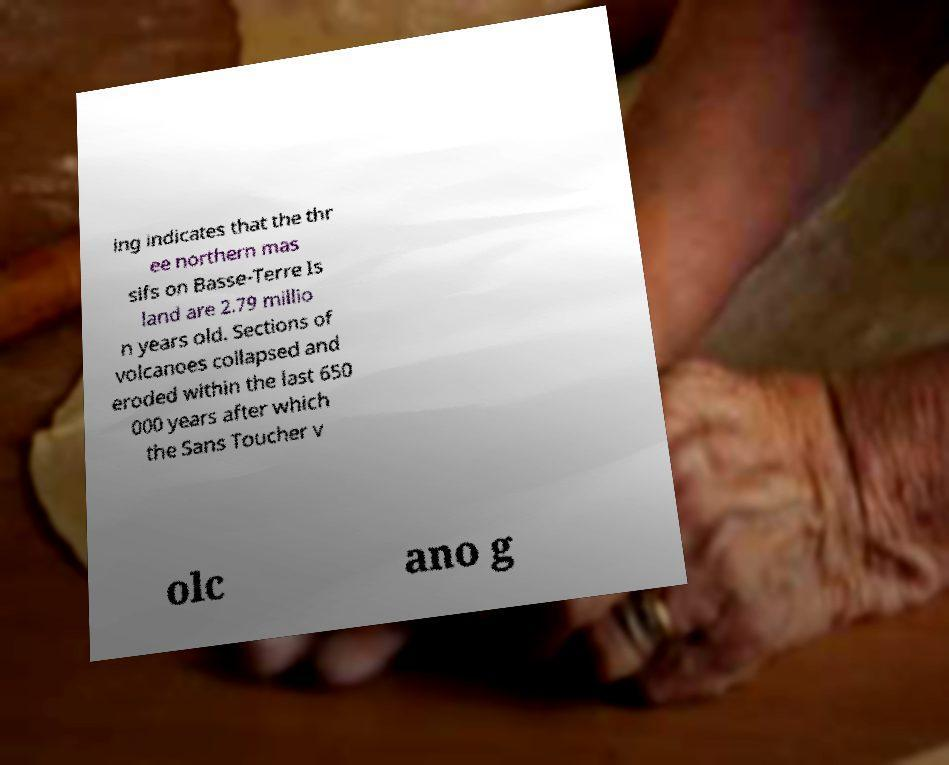Please identify and transcribe the text found in this image. ing indicates that the thr ee northern mas sifs on Basse-Terre Is land are 2.79 millio n years old. Sections of volcanoes collapsed and eroded within the last 650 000 years after which the Sans Toucher v olc ano g 